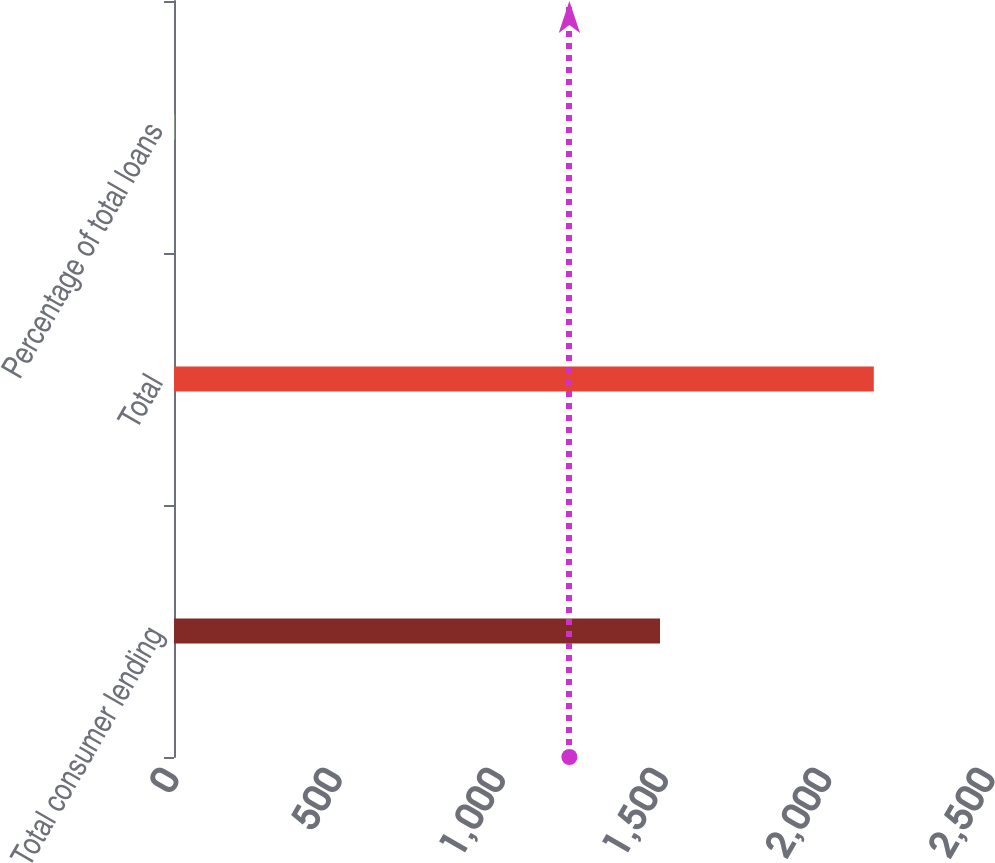Convert chart to OTSL. <chart><loc_0><loc_0><loc_500><loc_500><bar_chart><fcel>Total consumer lending<fcel>Total<fcel>Percentage of total loans<nl><fcel>1489<fcel>2144<fcel>1.02<nl></chart> 